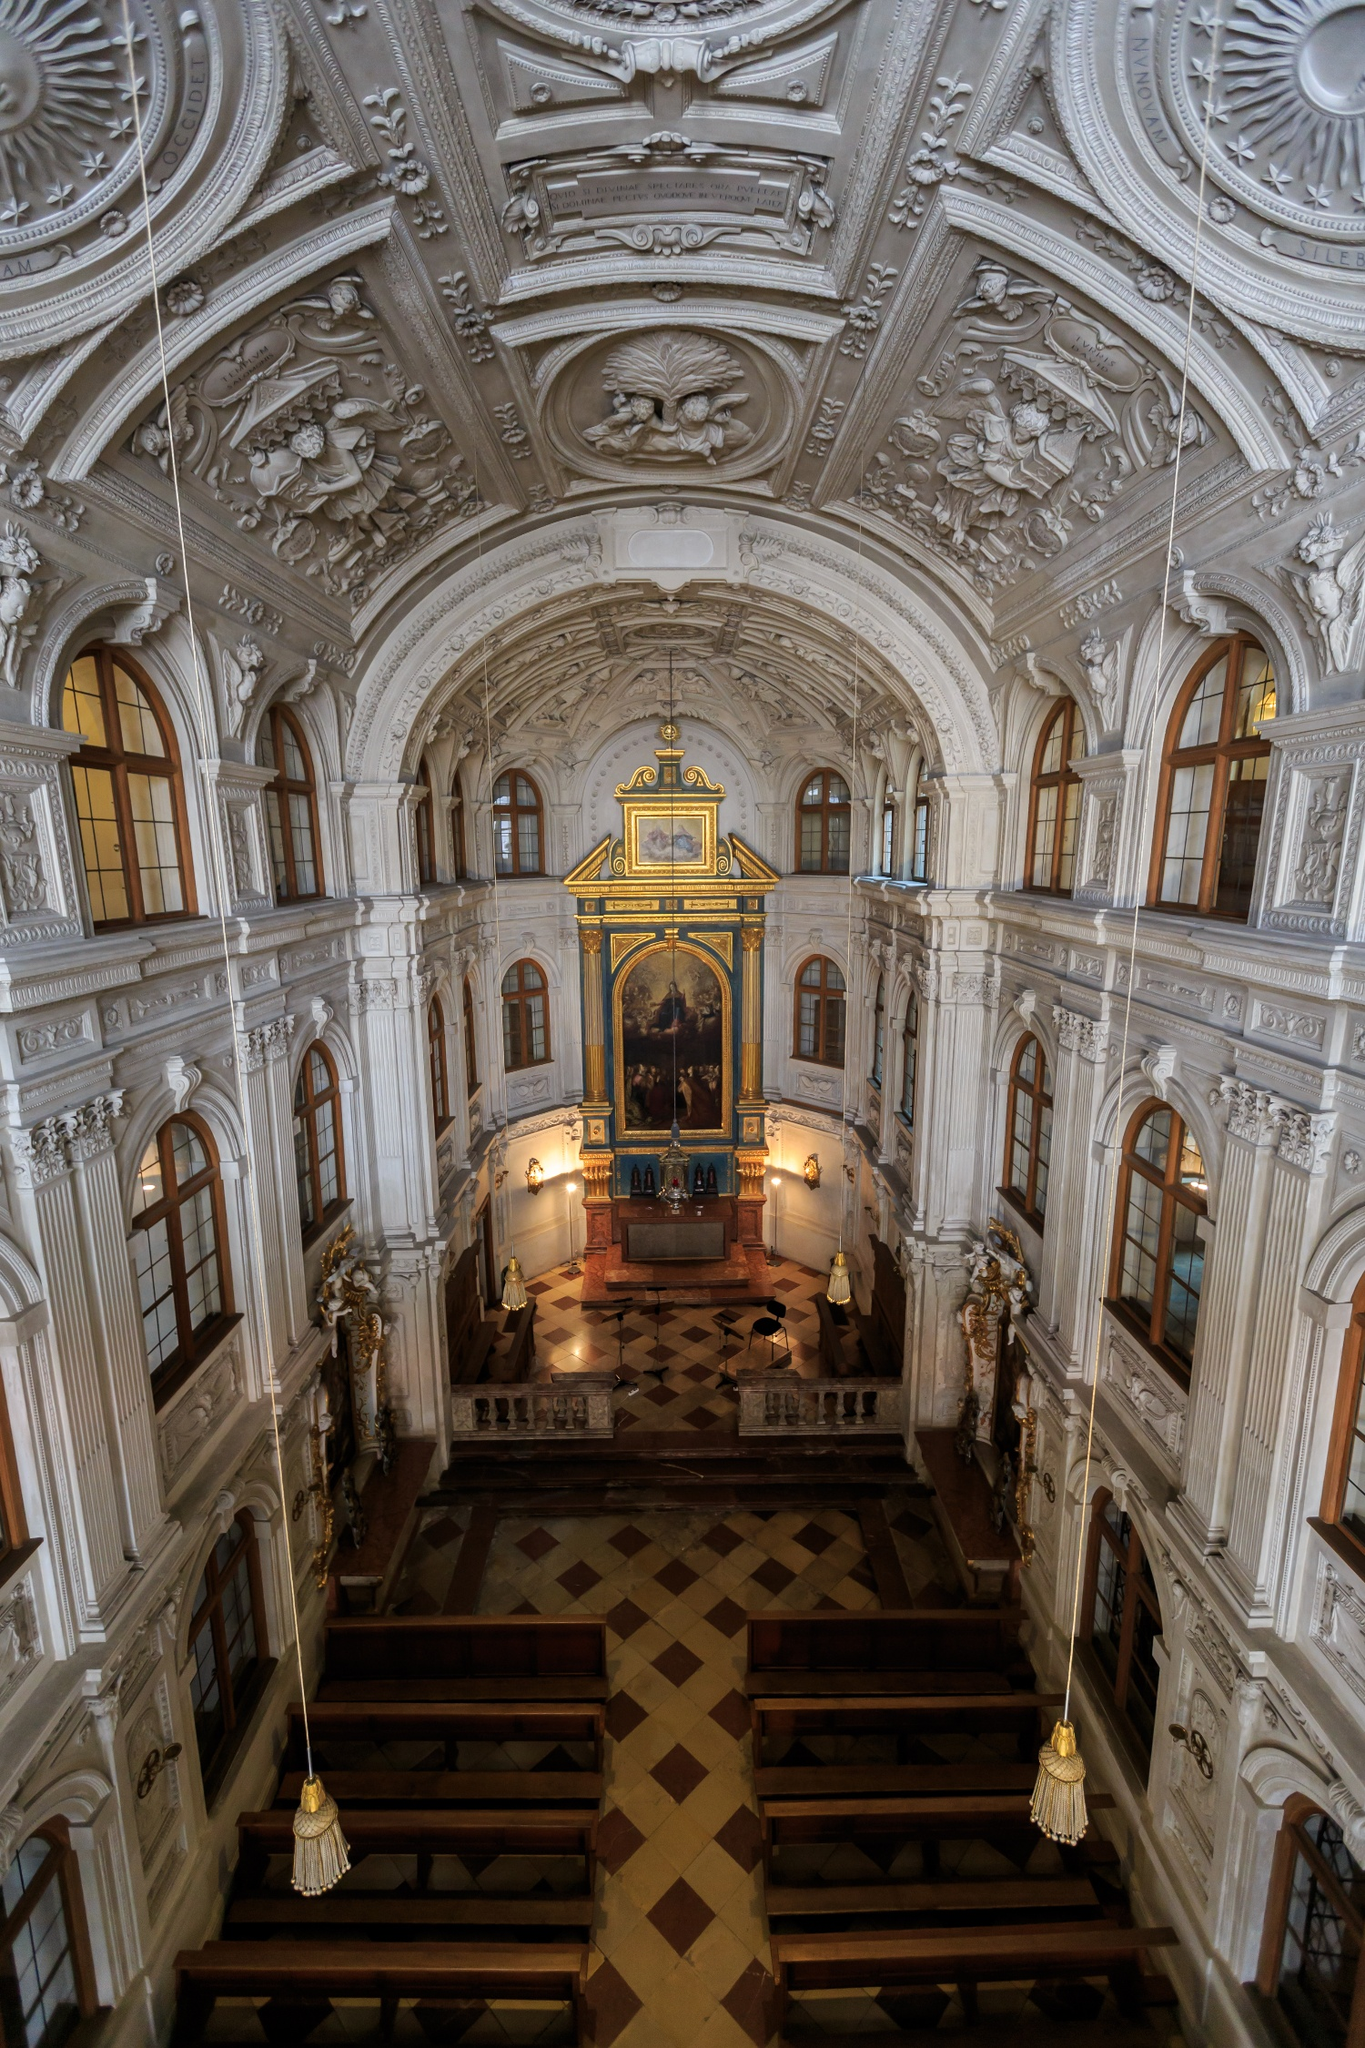Can you provide a brief history of this church? The Hofkirche, also known as the Dresden Cathedral, is one of the most significant landmarks in Dresden, Germany. Built in the 18th century by order of Frederick Augustus II, it was constructed to serve as the court church for the Electorate of Saxony. Designed by Italian architect Gaetano Chiaveri, the church is a prime example of baroque architecture, featuring elaborate interior decorations and significant artworks. Despite suffering severe damage during World War II, the church was meticulously restored to its former glory and continues to be an important religious and cultural site in Dresden. 